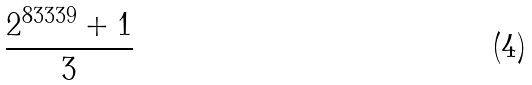Convert formula to latex. <formula><loc_0><loc_0><loc_500><loc_500>\frac { 2 ^ { 8 3 3 3 9 } + 1 } { 3 }</formula> 